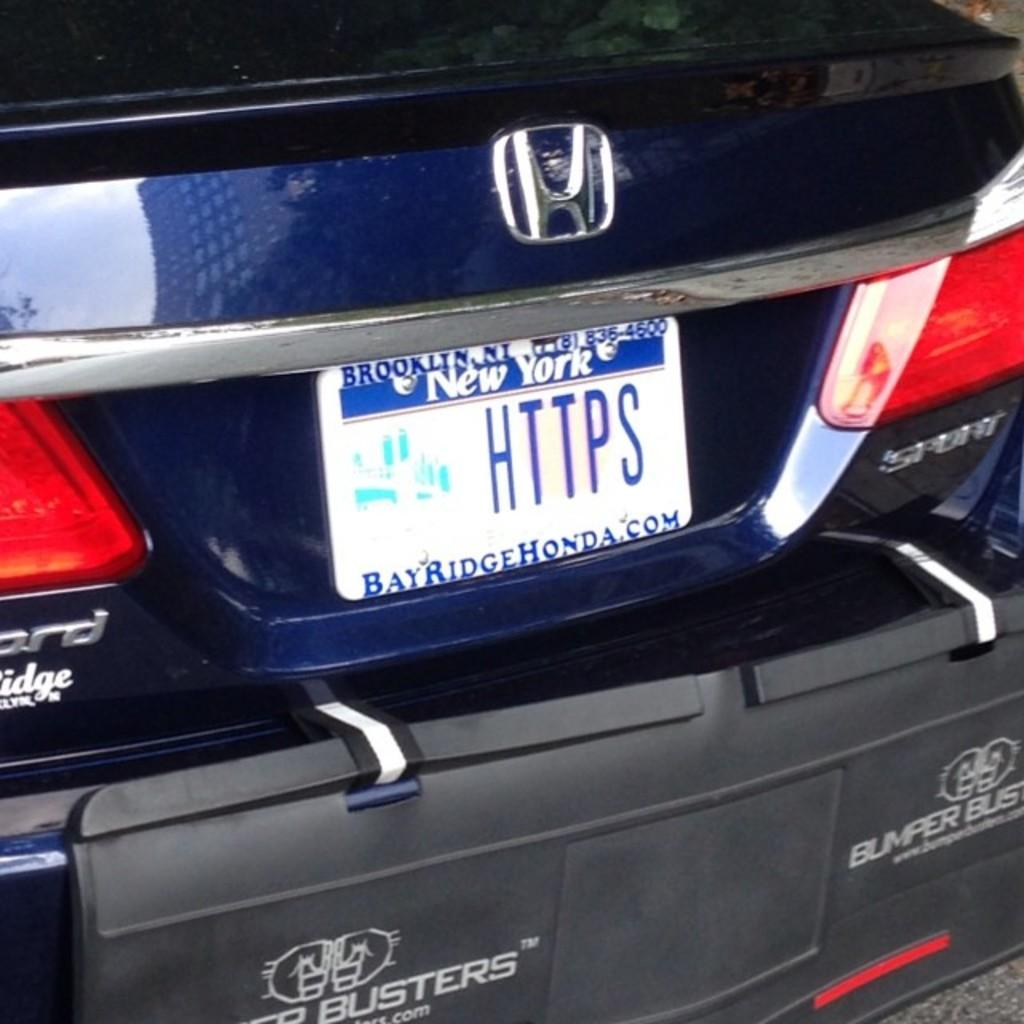<image>
Render a clear and concise summary of the photo. Honda sport car that contains a New york tag 